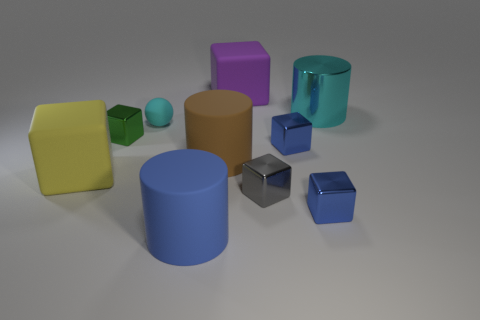Subtract all brown cylinders. How many cylinders are left? 2 Subtract all green balls. How many blue cubes are left? 2 Subtract all blue cylinders. How many cylinders are left? 2 Add 1 large brown objects. How many large brown objects are left? 2 Add 9 gray metallic blocks. How many gray metallic blocks exist? 10 Subtract 0 purple cylinders. How many objects are left? 10 Subtract all balls. How many objects are left? 9 Subtract 2 cylinders. How many cylinders are left? 1 Subtract all brown balls. Subtract all yellow cubes. How many balls are left? 1 Subtract all cyan shiny cylinders. Subtract all big purple things. How many objects are left? 8 